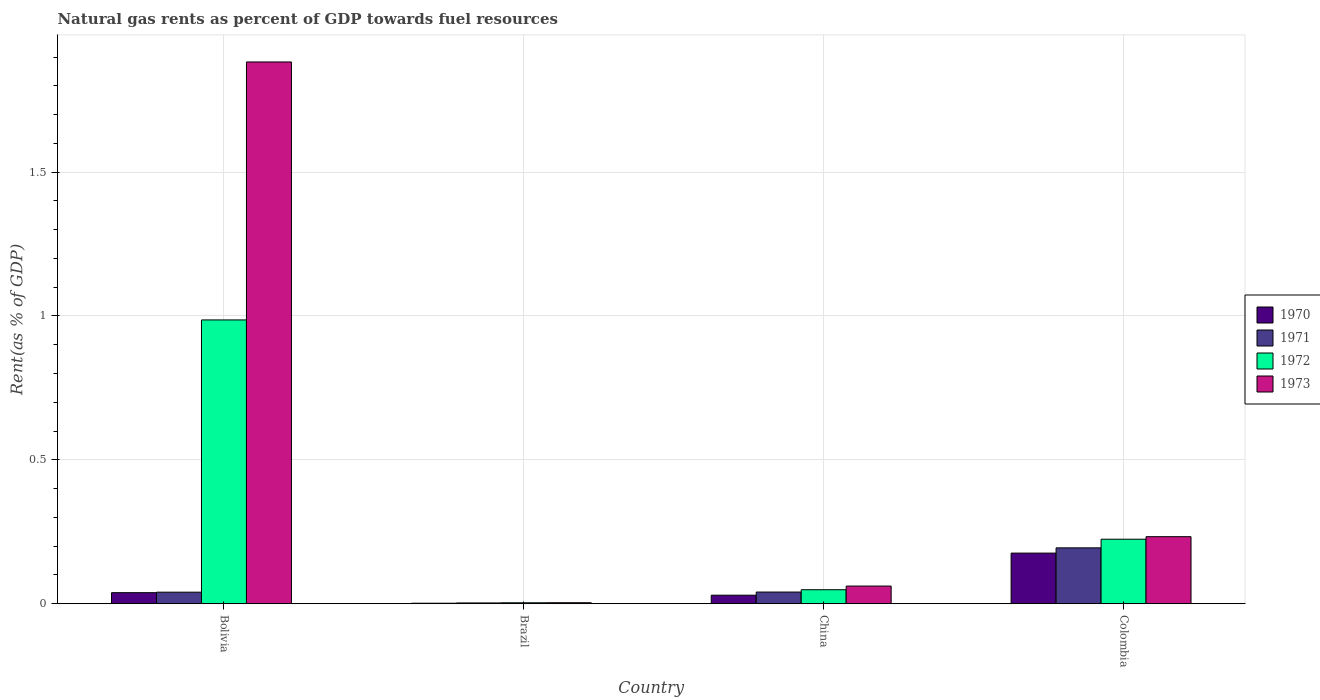How many groups of bars are there?
Offer a terse response. 4. Are the number of bars on each tick of the X-axis equal?
Keep it short and to the point. Yes. How many bars are there on the 4th tick from the left?
Your answer should be very brief. 4. How many bars are there on the 1st tick from the right?
Your answer should be compact. 4. What is the matural gas rent in 1973 in Colombia?
Give a very brief answer. 0.23. Across all countries, what is the maximum matural gas rent in 1972?
Your answer should be very brief. 0.99. Across all countries, what is the minimum matural gas rent in 1972?
Offer a very short reply. 0. In which country was the matural gas rent in 1973 minimum?
Provide a short and direct response. Brazil. What is the total matural gas rent in 1973 in the graph?
Keep it short and to the point. 2.18. What is the difference between the matural gas rent in 1971 in Brazil and that in China?
Offer a terse response. -0.04. What is the difference between the matural gas rent in 1972 in China and the matural gas rent in 1971 in Brazil?
Keep it short and to the point. 0.05. What is the average matural gas rent in 1971 per country?
Give a very brief answer. 0.07. What is the difference between the matural gas rent of/in 1972 and matural gas rent of/in 1971 in Colombia?
Keep it short and to the point. 0.03. What is the ratio of the matural gas rent in 1971 in Brazil to that in Colombia?
Give a very brief answer. 0.01. Is the matural gas rent in 1972 in Brazil less than that in China?
Provide a short and direct response. Yes. What is the difference between the highest and the second highest matural gas rent in 1970?
Your response must be concise. 0.15. What is the difference between the highest and the lowest matural gas rent in 1972?
Offer a terse response. 0.98. In how many countries, is the matural gas rent in 1971 greater than the average matural gas rent in 1971 taken over all countries?
Offer a terse response. 1. Is the sum of the matural gas rent in 1972 in Bolivia and Brazil greater than the maximum matural gas rent in 1973 across all countries?
Your answer should be very brief. No. What does the 4th bar from the right in China represents?
Offer a very short reply. 1970. Is it the case that in every country, the sum of the matural gas rent in 1973 and matural gas rent in 1970 is greater than the matural gas rent in 1971?
Give a very brief answer. Yes. Are all the bars in the graph horizontal?
Provide a succinct answer. No. What is the difference between two consecutive major ticks on the Y-axis?
Your response must be concise. 0.5. Are the values on the major ticks of Y-axis written in scientific E-notation?
Provide a succinct answer. No. Does the graph contain any zero values?
Make the answer very short. No. How are the legend labels stacked?
Your answer should be compact. Vertical. What is the title of the graph?
Offer a very short reply. Natural gas rents as percent of GDP towards fuel resources. Does "2010" appear as one of the legend labels in the graph?
Keep it short and to the point. No. What is the label or title of the X-axis?
Provide a short and direct response. Country. What is the label or title of the Y-axis?
Provide a succinct answer. Rent(as % of GDP). What is the Rent(as % of GDP) of 1970 in Bolivia?
Offer a very short reply. 0.04. What is the Rent(as % of GDP) of 1971 in Bolivia?
Ensure brevity in your answer.  0.04. What is the Rent(as % of GDP) of 1972 in Bolivia?
Give a very brief answer. 0.99. What is the Rent(as % of GDP) in 1973 in Bolivia?
Keep it short and to the point. 1.88. What is the Rent(as % of GDP) of 1970 in Brazil?
Your response must be concise. 0. What is the Rent(as % of GDP) in 1971 in Brazil?
Provide a succinct answer. 0. What is the Rent(as % of GDP) of 1972 in Brazil?
Ensure brevity in your answer.  0. What is the Rent(as % of GDP) in 1973 in Brazil?
Your response must be concise. 0. What is the Rent(as % of GDP) of 1970 in China?
Keep it short and to the point. 0.03. What is the Rent(as % of GDP) in 1971 in China?
Give a very brief answer. 0.04. What is the Rent(as % of GDP) of 1972 in China?
Your answer should be very brief. 0.05. What is the Rent(as % of GDP) in 1973 in China?
Provide a succinct answer. 0.06. What is the Rent(as % of GDP) of 1970 in Colombia?
Provide a short and direct response. 0.18. What is the Rent(as % of GDP) of 1971 in Colombia?
Provide a short and direct response. 0.19. What is the Rent(as % of GDP) of 1972 in Colombia?
Make the answer very short. 0.22. What is the Rent(as % of GDP) of 1973 in Colombia?
Your response must be concise. 0.23. Across all countries, what is the maximum Rent(as % of GDP) of 1970?
Give a very brief answer. 0.18. Across all countries, what is the maximum Rent(as % of GDP) in 1971?
Your answer should be compact. 0.19. Across all countries, what is the maximum Rent(as % of GDP) of 1972?
Provide a succinct answer. 0.99. Across all countries, what is the maximum Rent(as % of GDP) of 1973?
Give a very brief answer. 1.88. Across all countries, what is the minimum Rent(as % of GDP) in 1970?
Keep it short and to the point. 0. Across all countries, what is the minimum Rent(as % of GDP) in 1971?
Ensure brevity in your answer.  0. Across all countries, what is the minimum Rent(as % of GDP) in 1972?
Your response must be concise. 0. Across all countries, what is the minimum Rent(as % of GDP) of 1973?
Your response must be concise. 0. What is the total Rent(as % of GDP) in 1970 in the graph?
Keep it short and to the point. 0.25. What is the total Rent(as % of GDP) in 1971 in the graph?
Make the answer very short. 0.28. What is the total Rent(as % of GDP) in 1972 in the graph?
Ensure brevity in your answer.  1.26. What is the total Rent(as % of GDP) of 1973 in the graph?
Provide a short and direct response. 2.18. What is the difference between the Rent(as % of GDP) in 1970 in Bolivia and that in Brazil?
Your answer should be very brief. 0.04. What is the difference between the Rent(as % of GDP) of 1971 in Bolivia and that in Brazil?
Give a very brief answer. 0.04. What is the difference between the Rent(as % of GDP) in 1973 in Bolivia and that in Brazil?
Offer a terse response. 1.88. What is the difference between the Rent(as % of GDP) of 1970 in Bolivia and that in China?
Make the answer very short. 0.01. What is the difference between the Rent(as % of GDP) in 1971 in Bolivia and that in China?
Your response must be concise. -0. What is the difference between the Rent(as % of GDP) in 1972 in Bolivia and that in China?
Provide a succinct answer. 0.94. What is the difference between the Rent(as % of GDP) of 1973 in Bolivia and that in China?
Provide a short and direct response. 1.82. What is the difference between the Rent(as % of GDP) in 1970 in Bolivia and that in Colombia?
Offer a very short reply. -0.14. What is the difference between the Rent(as % of GDP) of 1971 in Bolivia and that in Colombia?
Give a very brief answer. -0.15. What is the difference between the Rent(as % of GDP) of 1972 in Bolivia and that in Colombia?
Provide a short and direct response. 0.76. What is the difference between the Rent(as % of GDP) in 1973 in Bolivia and that in Colombia?
Provide a succinct answer. 1.65. What is the difference between the Rent(as % of GDP) in 1970 in Brazil and that in China?
Provide a short and direct response. -0.03. What is the difference between the Rent(as % of GDP) in 1971 in Brazil and that in China?
Provide a succinct answer. -0.04. What is the difference between the Rent(as % of GDP) of 1972 in Brazil and that in China?
Your answer should be compact. -0.05. What is the difference between the Rent(as % of GDP) of 1973 in Brazil and that in China?
Provide a succinct answer. -0.06. What is the difference between the Rent(as % of GDP) in 1970 in Brazil and that in Colombia?
Provide a short and direct response. -0.17. What is the difference between the Rent(as % of GDP) of 1971 in Brazil and that in Colombia?
Provide a succinct answer. -0.19. What is the difference between the Rent(as % of GDP) in 1972 in Brazil and that in Colombia?
Make the answer very short. -0.22. What is the difference between the Rent(as % of GDP) in 1973 in Brazil and that in Colombia?
Your response must be concise. -0.23. What is the difference between the Rent(as % of GDP) of 1970 in China and that in Colombia?
Keep it short and to the point. -0.15. What is the difference between the Rent(as % of GDP) in 1971 in China and that in Colombia?
Ensure brevity in your answer.  -0.15. What is the difference between the Rent(as % of GDP) of 1972 in China and that in Colombia?
Your answer should be very brief. -0.18. What is the difference between the Rent(as % of GDP) of 1973 in China and that in Colombia?
Ensure brevity in your answer.  -0.17. What is the difference between the Rent(as % of GDP) of 1970 in Bolivia and the Rent(as % of GDP) of 1971 in Brazil?
Keep it short and to the point. 0.04. What is the difference between the Rent(as % of GDP) of 1970 in Bolivia and the Rent(as % of GDP) of 1972 in Brazil?
Keep it short and to the point. 0.04. What is the difference between the Rent(as % of GDP) of 1970 in Bolivia and the Rent(as % of GDP) of 1973 in Brazil?
Give a very brief answer. 0.03. What is the difference between the Rent(as % of GDP) of 1971 in Bolivia and the Rent(as % of GDP) of 1972 in Brazil?
Your answer should be very brief. 0.04. What is the difference between the Rent(as % of GDP) of 1971 in Bolivia and the Rent(as % of GDP) of 1973 in Brazil?
Ensure brevity in your answer.  0.04. What is the difference between the Rent(as % of GDP) in 1972 in Bolivia and the Rent(as % of GDP) in 1973 in Brazil?
Ensure brevity in your answer.  0.98. What is the difference between the Rent(as % of GDP) in 1970 in Bolivia and the Rent(as % of GDP) in 1971 in China?
Make the answer very short. -0. What is the difference between the Rent(as % of GDP) of 1970 in Bolivia and the Rent(as % of GDP) of 1972 in China?
Offer a very short reply. -0.01. What is the difference between the Rent(as % of GDP) of 1970 in Bolivia and the Rent(as % of GDP) of 1973 in China?
Offer a terse response. -0.02. What is the difference between the Rent(as % of GDP) of 1971 in Bolivia and the Rent(as % of GDP) of 1972 in China?
Your answer should be compact. -0.01. What is the difference between the Rent(as % of GDP) in 1971 in Bolivia and the Rent(as % of GDP) in 1973 in China?
Your answer should be very brief. -0.02. What is the difference between the Rent(as % of GDP) of 1972 in Bolivia and the Rent(as % of GDP) of 1973 in China?
Offer a terse response. 0.92. What is the difference between the Rent(as % of GDP) of 1970 in Bolivia and the Rent(as % of GDP) of 1971 in Colombia?
Keep it short and to the point. -0.16. What is the difference between the Rent(as % of GDP) of 1970 in Bolivia and the Rent(as % of GDP) of 1972 in Colombia?
Offer a very short reply. -0.19. What is the difference between the Rent(as % of GDP) in 1970 in Bolivia and the Rent(as % of GDP) in 1973 in Colombia?
Ensure brevity in your answer.  -0.19. What is the difference between the Rent(as % of GDP) of 1971 in Bolivia and the Rent(as % of GDP) of 1972 in Colombia?
Ensure brevity in your answer.  -0.18. What is the difference between the Rent(as % of GDP) in 1971 in Bolivia and the Rent(as % of GDP) in 1973 in Colombia?
Ensure brevity in your answer.  -0.19. What is the difference between the Rent(as % of GDP) in 1972 in Bolivia and the Rent(as % of GDP) in 1973 in Colombia?
Offer a terse response. 0.75. What is the difference between the Rent(as % of GDP) in 1970 in Brazil and the Rent(as % of GDP) in 1971 in China?
Offer a terse response. -0.04. What is the difference between the Rent(as % of GDP) in 1970 in Brazil and the Rent(as % of GDP) in 1972 in China?
Give a very brief answer. -0.05. What is the difference between the Rent(as % of GDP) of 1970 in Brazil and the Rent(as % of GDP) of 1973 in China?
Offer a terse response. -0.06. What is the difference between the Rent(as % of GDP) of 1971 in Brazil and the Rent(as % of GDP) of 1972 in China?
Keep it short and to the point. -0.05. What is the difference between the Rent(as % of GDP) of 1971 in Brazil and the Rent(as % of GDP) of 1973 in China?
Ensure brevity in your answer.  -0.06. What is the difference between the Rent(as % of GDP) of 1972 in Brazil and the Rent(as % of GDP) of 1973 in China?
Offer a very short reply. -0.06. What is the difference between the Rent(as % of GDP) of 1970 in Brazil and the Rent(as % of GDP) of 1971 in Colombia?
Provide a succinct answer. -0.19. What is the difference between the Rent(as % of GDP) in 1970 in Brazil and the Rent(as % of GDP) in 1972 in Colombia?
Your response must be concise. -0.22. What is the difference between the Rent(as % of GDP) in 1970 in Brazil and the Rent(as % of GDP) in 1973 in Colombia?
Provide a short and direct response. -0.23. What is the difference between the Rent(as % of GDP) in 1971 in Brazil and the Rent(as % of GDP) in 1972 in Colombia?
Keep it short and to the point. -0.22. What is the difference between the Rent(as % of GDP) in 1971 in Brazil and the Rent(as % of GDP) in 1973 in Colombia?
Your answer should be compact. -0.23. What is the difference between the Rent(as % of GDP) of 1972 in Brazil and the Rent(as % of GDP) of 1973 in Colombia?
Your answer should be compact. -0.23. What is the difference between the Rent(as % of GDP) in 1970 in China and the Rent(as % of GDP) in 1971 in Colombia?
Give a very brief answer. -0.16. What is the difference between the Rent(as % of GDP) of 1970 in China and the Rent(as % of GDP) of 1972 in Colombia?
Give a very brief answer. -0.19. What is the difference between the Rent(as % of GDP) of 1970 in China and the Rent(as % of GDP) of 1973 in Colombia?
Offer a terse response. -0.2. What is the difference between the Rent(as % of GDP) of 1971 in China and the Rent(as % of GDP) of 1972 in Colombia?
Provide a succinct answer. -0.18. What is the difference between the Rent(as % of GDP) in 1971 in China and the Rent(as % of GDP) in 1973 in Colombia?
Keep it short and to the point. -0.19. What is the difference between the Rent(as % of GDP) in 1972 in China and the Rent(as % of GDP) in 1973 in Colombia?
Give a very brief answer. -0.18. What is the average Rent(as % of GDP) of 1970 per country?
Ensure brevity in your answer.  0.06. What is the average Rent(as % of GDP) in 1971 per country?
Give a very brief answer. 0.07. What is the average Rent(as % of GDP) in 1972 per country?
Ensure brevity in your answer.  0.32. What is the average Rent(as % of GDP) of 1973 per country?
Make the answer very short. 0.55. What is the difference between the Rent(as % of GDP) of 1970 and Rent(as % of GDP) of 1971 in Bolivia?
Your response must be concise. -0. What is the difference between the Rent(as % of GDP) in 1970 and Rent(as % of GDP) in 1972 in Bolivia?
Keep it short and to the point. -0.95. What is the difference between the Rent(as % of GDP) in 1970 and Rent(as % of GDP) in 1973 in Bolivia?
Offer a very short reply. -1.84. What is the difference between the Rent(as % of GDP) of 1971 and Rent(as % of GDP) of 1972 in Bolivia?
Ensure brevity in your answer.  -0.95. What is the difference between the Rent(as % of GDP) of 1971 and Rent(as % of GDP) of 1973 in Bolivia?
Provide a short and direct response. -1.84. What is the difference between the Rent(as % of GDP) of 1972 and Rent(as % of GDP) of 1973 in Bolivia?
Offer a terse response. -0.9. What is the difference between the Rent(as % of GDP) of 1970 and Rent(as % of GDP) of 1971 in Brazil?
Offer a terse response. -0. What is the difference between the Rent(as % of GDP) of 1970 and Rent(as % of GDP) of 1972 in Brazil?
Make the answer very short. -0. What is the difference between the Rent(as % of GDP) of 1970 and Rent(as % of GDP) of 1973 in Brazil?
Give a very brief answer. -0. What is the difference between the Rent(as % of GDP) of 1971 and Rent(as % of GDP) of 1972 in Brazil?
Provide a short and direct response. -0. What is the difference between the Rent(as % of GDP) of 1971 and Rent(as % of GDP) of 1973 in Brazil?
Provide a succinct answer. -0. What is the difference between the Rent(as % of GDP) in 1972 and Rent(as % of GDP) in 1973 in Brazil?
Your response must be concise. -0. What is the difference between the Rent(as % of GDP) in 1970 and Rent(as % of GDP) in 1971 in China?
Your answer should be very brief. -0.01. What is the difference between the Rent(as % of GDP) in 1970 and Rent(as % of GDP) in 1972 in China?
Make the answer very short. -0.02. What is the difference between the Rent(as % of GDP) in 1970 and Rent(as % of GDP) in 1973 in China?
Give a very brief answer. -0.03. What is the difference between the Rent(as % of GDP) of 1971 and Rent(as % of GDP) of 1972 in China?
Offer a very short reply. -0.01. What is the difference between the Rent(as % of GDP) in 1971 and Rent(as % of GDP) in 1973 in China?
Provide a short and direct response. -0.02. What is the difference between the Rent(as % of GDP) of 1972 and Rent(as % of GDP) of 1973 in China?
Offer a very short reply. -0.01. What is the difference between the Rent(as % of GDP) in 1970 and Rent(as % of GDP) in 1971 in Colombia?
Keep it short and to the point. -0.02. What is the difference between the Rent(as % of GDP) of 1970 and Rent(as % of GDP) of 1972 in Colombia?
Your answer should be compact. -0.05. What is the difference between the Rent(as % of GDP) in 1970 and Rent(as % of GDP) in 1973 in Colombia?
Provide a short and direct response. -0.06. What is the difference between the Rent(as % of GDP) of 1971 and Rent(as % of GDP) of 1972 in Colombia?
Offer a very short reply. -0.03. What is the difference between the Rent(as % of GDP) in 1971 and Rent(as % of GDP) in 1973 in Colombia?
Provide a succinct answer. -0.04. What is the difference between the Rent(as % of GDP) of 1972 and Rent(as % of GDP) of 1973 in Colombia?
Ensure brevity in your answer.  -0.01. What is the ratio of the Rent(as % of GDP) of 1970 in Bolivia to that in Brazil?
Provide a short and direct response. 21.58. What is the ratio of the Rent(as % of GDP) of 1971 in Bolivia to that in Brazil?
Keep it short and to the point. 14.62. What is the ratio of the Rent(as % of GDP) of 1972 in Bolivia to that in Brazil?
Make the answer very short. 297.41. What is the ratio of the Rent(as % of GDP) in 1973 in Bolivia to that in Brazil?
Offer a very short reply. 539.46. What is the ratio of the Rent(as % of GDP) of 1970 in Bolivia to that in China?
Give a very brief answer. 1.3. What is the ratio of the Rent(as % of GDP) of 1971 in Bolivia to that in China?
Ensure brevity in your answer.  0.99. What is the ratio of the Rent(as % of GDP) in 1972 in Bolivia to that in China?
Provide a short and direct response. 20.28. What is the ratio of the Rent(as % of GDP) in 1973 in Bolivia to that in China?
Your answer should be very brief. 30.65. What is the ratio of the Rent(as % of GDP) in 1970 in Bolivia to that in Colombia?
Keep it short and to the point. 0.22. What is the ratio of the Rent(as % of GDP) in 1971 in Bolivia to that in Colombia?
Offer a terse response. 0.21. What is the ratio of the Rent(as % of GDP) in 1972 in Bolivia to that in Colombia?
Provide a succinct answer. 4.4. What is the ratio of the Rent(as % of GDP) in 1973 in Bolivia to that in Colombia?
Your answer should be compact. 8.08. What is the ratio of the Rent(as % of GDP) of 1970 in Brazil to that in China?
Your answer should be compact. 0.06. What is the ratio of the Rent(as % of GDP) of 1971 in Brazil to that in China?
Your response must be concise. 0.07. What is the ratio of the Rent(as % of GDP) of 1972 in Brazil to that in China?
Provide a succinct answer. 0.07. What is the ratio of the Rent(as % of GDP) in 1973 in Brazil to that in China?
Your response must be concise. 0.06. What is the ratio of the Rent(as % of GDP) of 1970 in Brazil to that in Colombia?
Make the answer very short. 0.01. What is the ratio of the Rent(as % of GDP) in 1971 in Brazil to that in Colombia?
Offer a terse response. 0.01. What is the ratio of the Rent(as % of GDP) in 1972 in Brazil to that in Colombia?
Your answer should be compact. 0.01. What is the ratio of the Rent(as % of GDP) in 1973 in Brazil to that in Colombia?
Provide a succinct answer. 0.01. What is the ratio of the Rent(as % of GDP) of 1970 in China to that in Colombia?
Ensure brevity in your answer.  0.17. What is the ratio of the Rent(as % of GDP) in 1971 in China to that in Colombia?
Make the answer very short. 0.21. What is the ratio of the Rent(as % of GDP) of 1972 in China to that in Colombia?
Make the answer very short. 0.22. What is the ratio of the Rent(as % of GDP) in 1973 in China to that in Colombia?
Provide a short and direct response. 0.26. What is the difference between the highest and the second highest Rent(as % of GDP) of 1970?
Ensure brevity in your answer.  0.14. What is the difference between the highest and the second highest Rent(as % of GDP) in 1971?
Provide a short and direct response. 0.15. What is the difference between the highest and the second highest Rent(as % of GDP) in 1972?
Offer a very short reply. 0.76. What is the difference between the highest and the second highest Rent(as % of GDP) of 1973?
Your answer should be compact. 1.65. What is the difference between the highest and the lowest Rent(as % of GDP) of 1970?
Your answer should be compact. 0.17. What is the difference between the highest and the lowest Rent(as % of GDP) of 1971?
Keep it short and to the point. 0.19. What is the difference between the highest and the lowest Rent(as % of GDP) in 1973?
Your answer should be compact. 1.88. 